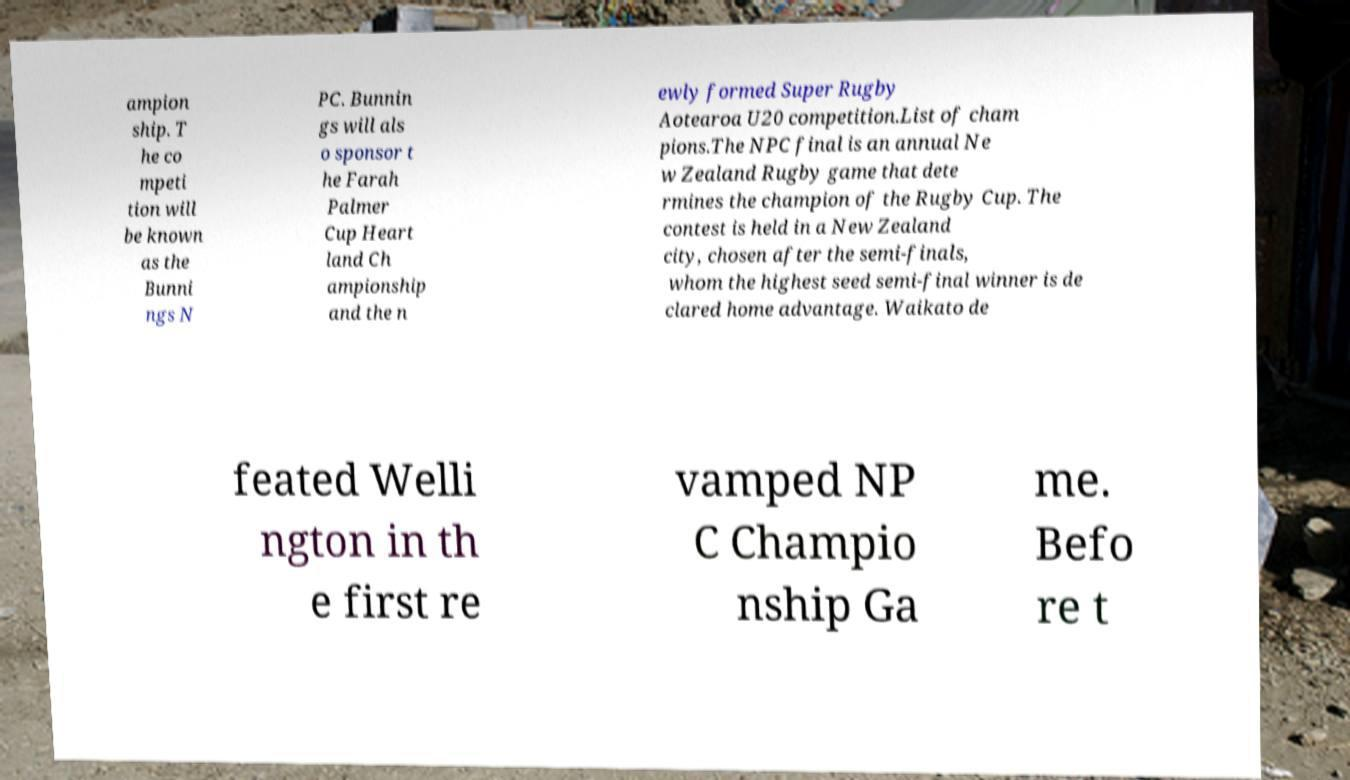Could you extract and type out the text from this image? ampion ship. T he co mpeti tion will be known as the Bunni ngs N PC. Bunnin gs will als o sponsor t he Farah Palmer Cup Heart land Ch ampionship and the n ewly formed Super Rugby Aotearoa U20 competition.List of cham pions.The NPC final is an annual Ne w Zealand Rugby game that dete rmines the champion of the Rugby Cup. The contest is held in a New Zealand city, chosen after the semi-finals, whom the highest seed semi-final winner is de clared home advantage. Waikato de feated Welli ngton in th e first re vamped NP C Champio nship Ga me. Befo re t 